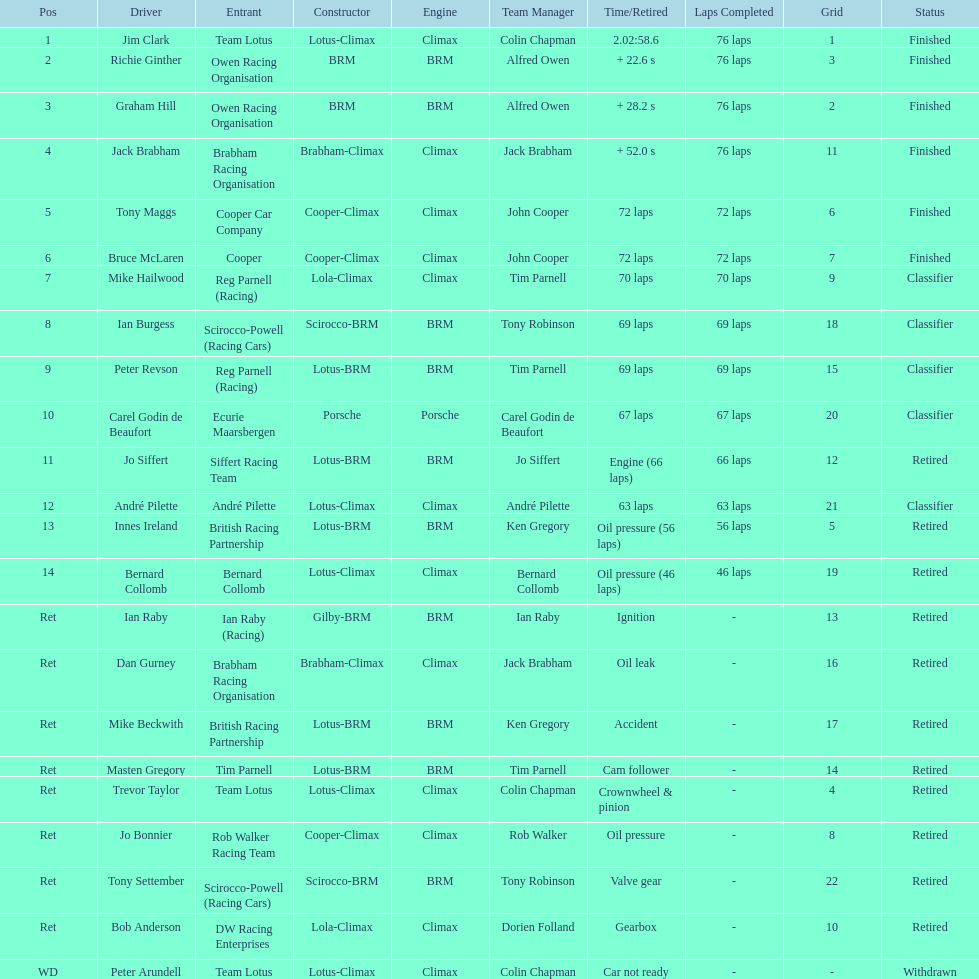Who came in earlier, tony maggs or jo siffert? Tony Maggs. 